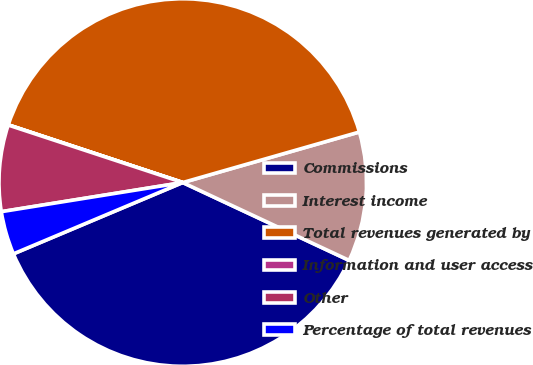<chart> <loc_0><loc_0><loc_500><loc_500><pie_chart><fcel>Commissions<fcel>Interest income<fcel>Total revenues generated by<fcel>Information and user access<fcel>Other<fcel>Percentage of total revenues<nl><fcel>36.69%<fcel>11.4%<fcel>40.48%<fcel>0.02%<fcel>7.6%<fcel>3.81%<nl></chart> 